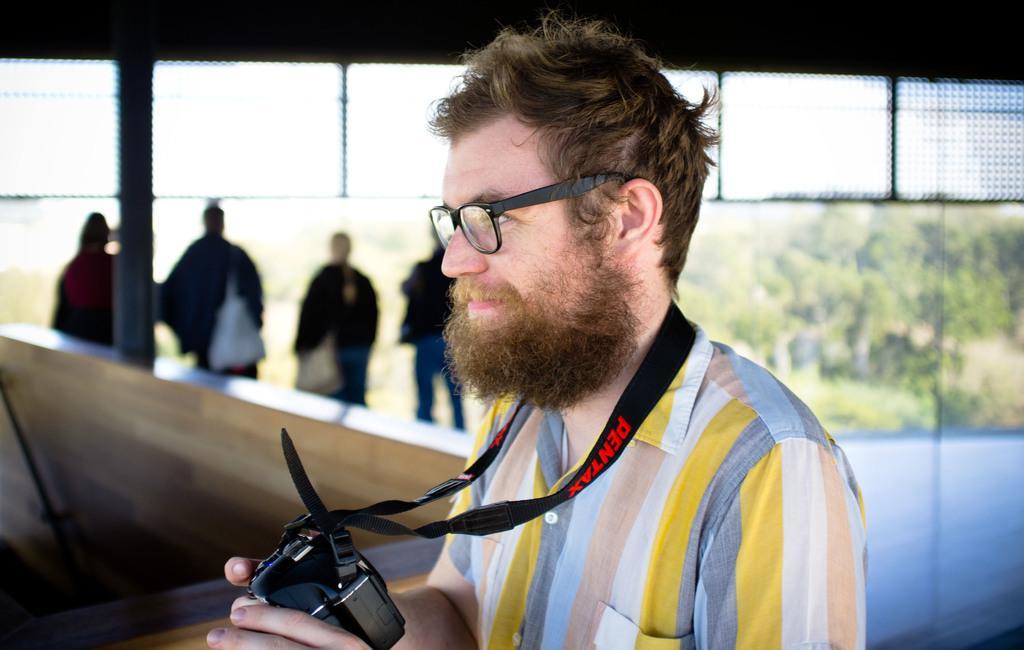Could you give a brief overview of what you see in this image? In this image there is a person holding a camera in his hand looks at something, behind the person there are four other people standing and looking through a glass wall, on the other side of the wall there are trees. 